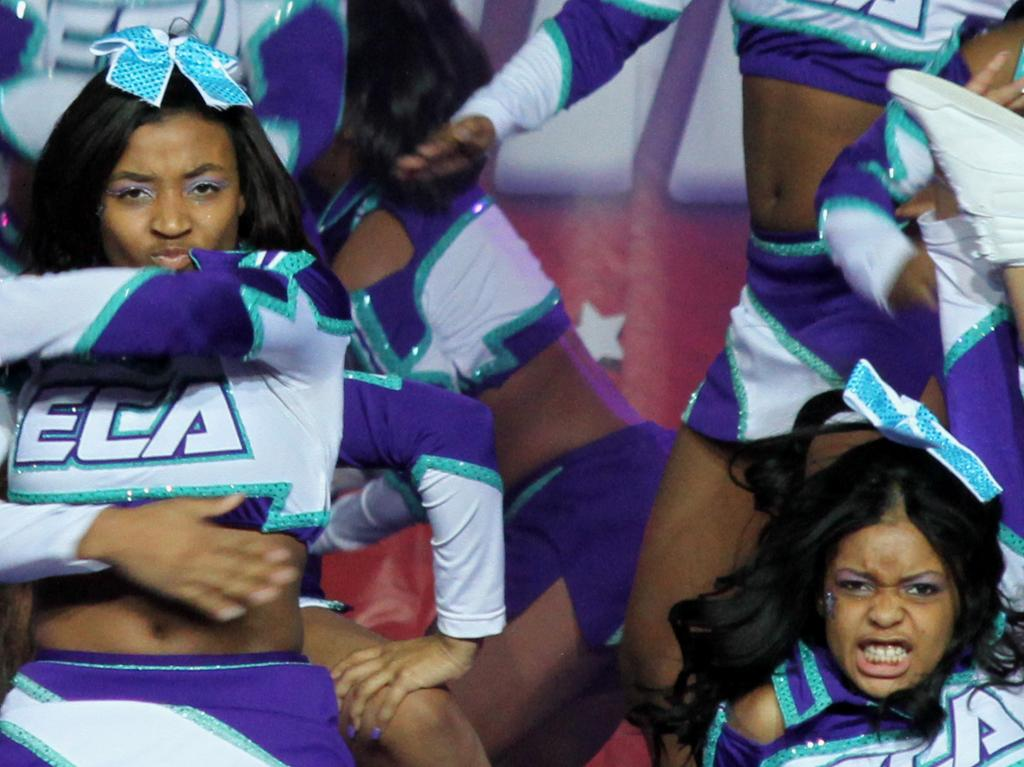Provide a one-sentence caption for the provided image. a shirt that has the letters ela on it. 